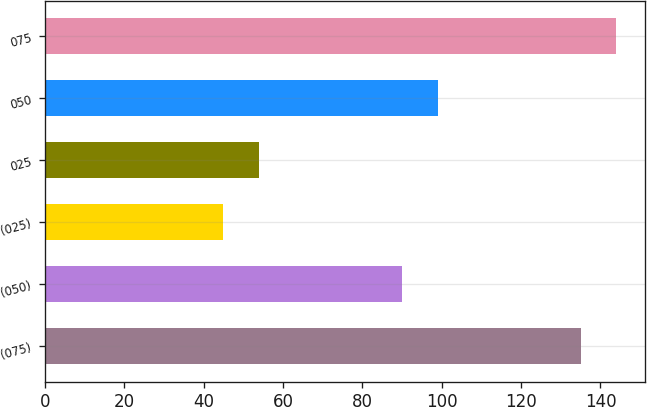<chart> <loc_0><loc_0><loc_500><loc_500><bar_chart><fcel>(075)<fcel>(050)<fcel>(025)<fcel>025<fcel>050<fcel>075<nl><fcel>135<fcel>90<fcel>45<fcel>54<fcel>99<fcel>144<nl></chart> 